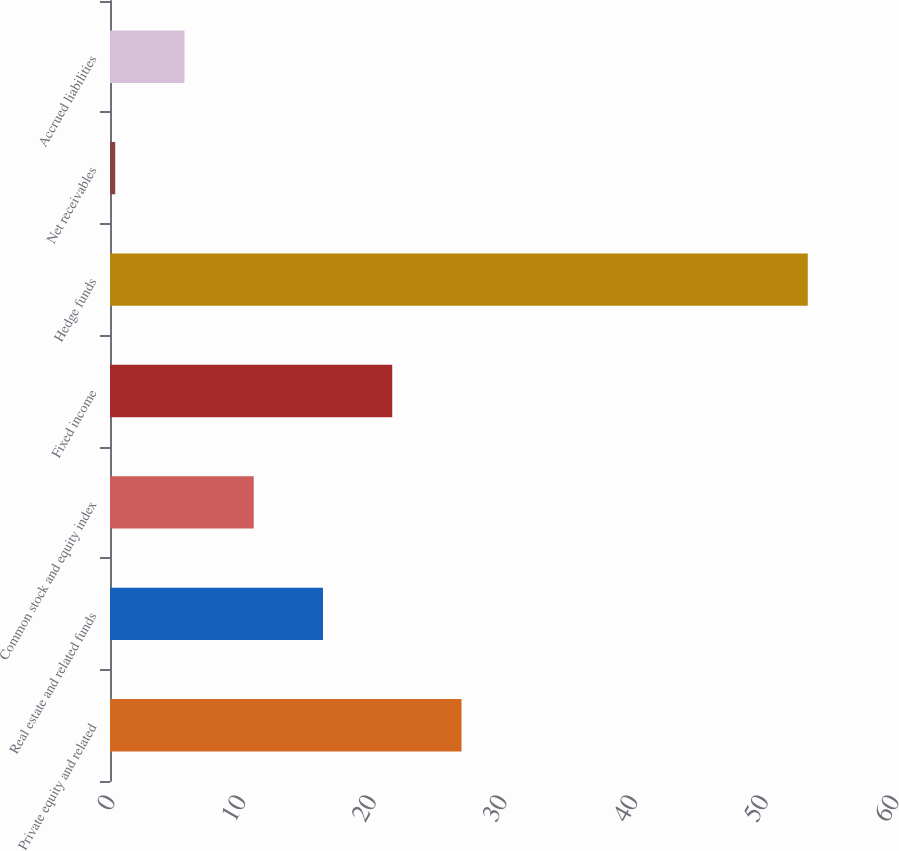Convert chart to OTSL. <chart><loc_0><loc_0><loc_500><loc_500><bar_chart><fcel>Private equity and related<fcel>Real estate and related funds<fcel>Common stock and equity index<fcel>Fixed income<fcel>Hedge funds<fcel>Net receivables<fcel>Accrued liabilities<nl><fcel>26.9<fcel>16.3<fcel>11<fcel>21.6<fcel>53.4<fcel>0.4<fcel>5.7<nl></chart> 